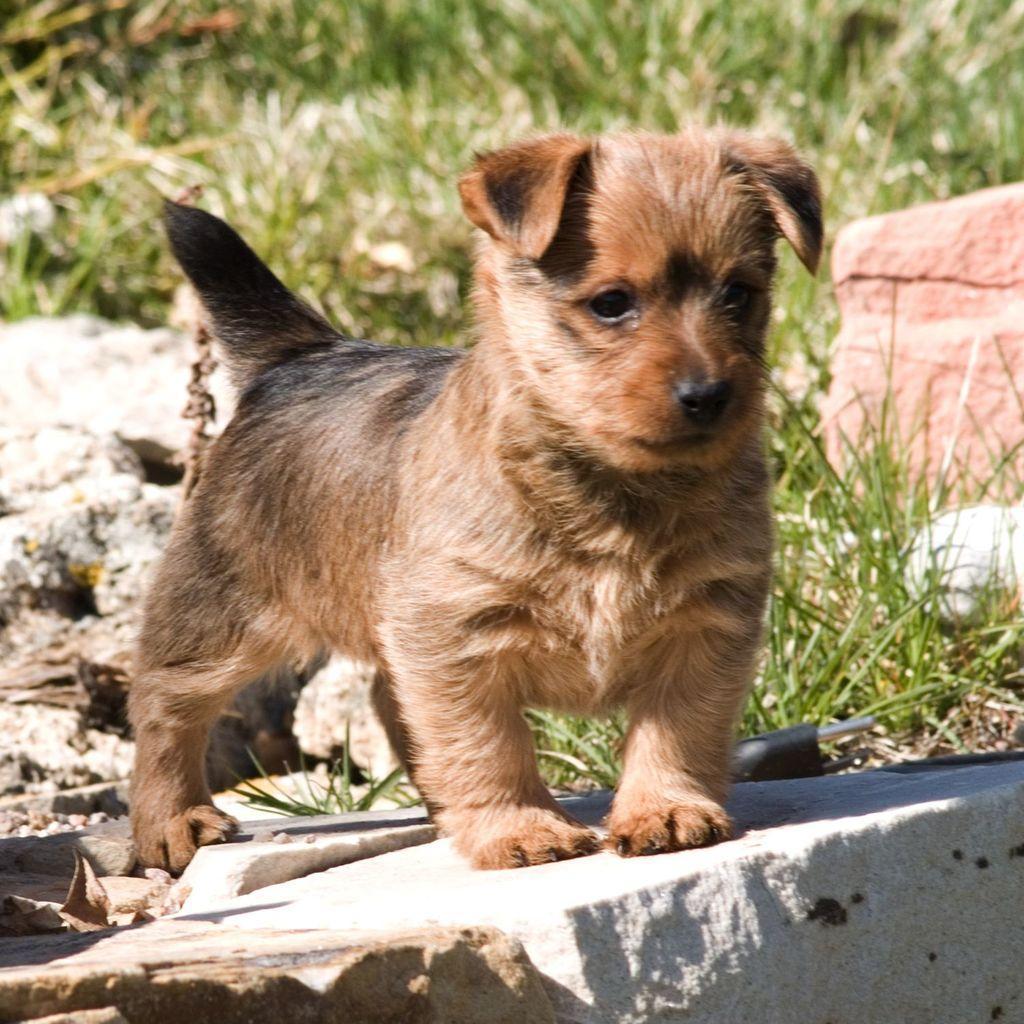Could you give a brief overview of what you see in this image? In this image we can see a dog standing on the stone and grass in the background. 